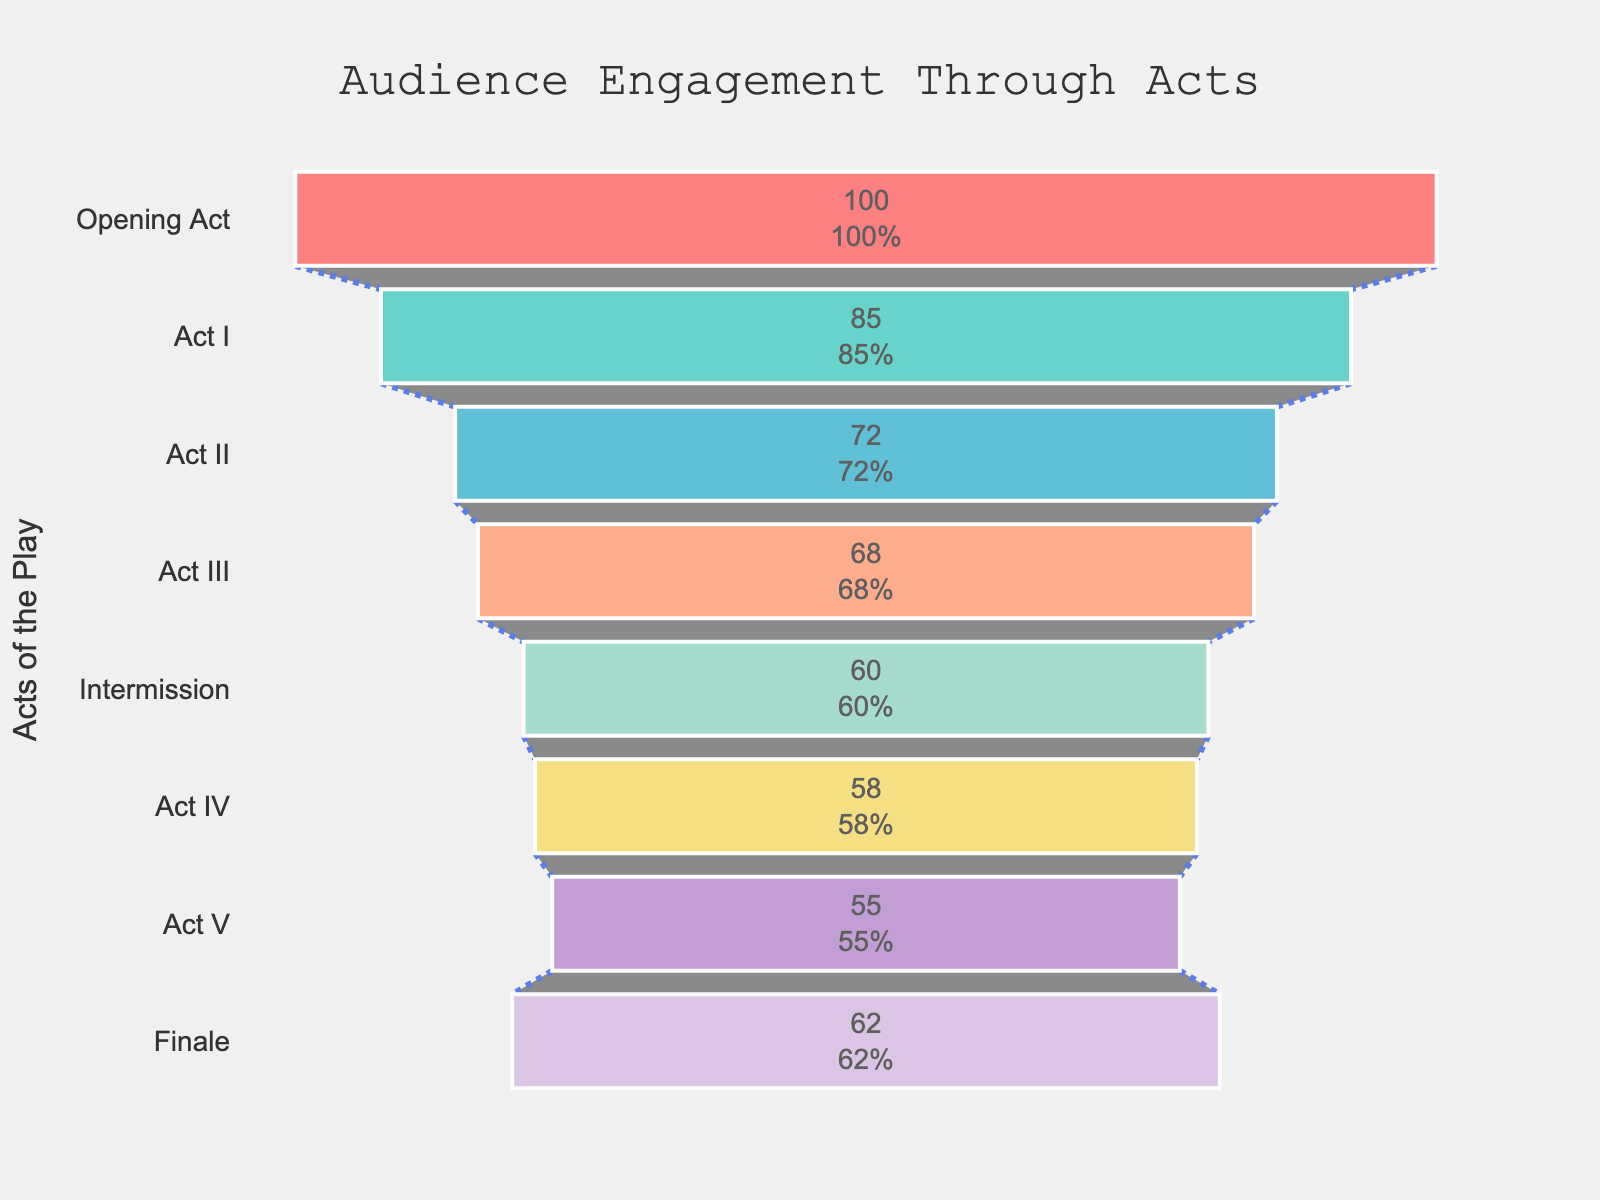What is the title of the funnel chart? The title of the chart is usually displayed prominently at the top of the figure and in this case, it reads "Audience Engagement Through Acts".
Answer: Audience Engagement Through Acts What are the highest and lowest levels of audience engagement? The highest engagement level can be found by looking for the tallest bar, which corresponds to the "Opening Act" with 100. The lowest is represented by the shortest bar, which is "Act V" at 55.
Answer: Highest: 100, Lowest: 55 What's the difference in audience engagement between the Opening Act and the Finale? First, identify the values of engagement for the Opening Act (100) and the Finale (62). Then, subtract the Finale's value from the Opening Act's value (100 - 62).
Answer: 38 Which act had an engagement level of 68? Look for the bar labeled with an engagement level of 68. The corresponding act is "Act III".
Answer: Act III How many acts have an audience engagement level greater than 70? Locate the bars whose values are higher than 70: Opening Act (100), Act I (85), Act II (72). Count these bars.
Answer: 3 By how much did the engagement level drop from Act II to Intermission? Identify the engagement levels of Act II (72) and Intermission (60). Subtract Intermission’s engagement from Act II’s engagement (72 - 60).
Answer: 12 Which act saw the biggest drop in engagement compared to the previous act? Calculate the difference in engagement levels between each pair of consecutive acts and identify the largest drop. The biggest drop is between the Opening Act (100) to Act I (85), which is 15. Similarly review other drops but this one is the greatest.
Answer: Act I What percentage of the initial engagement level did the audience retain by the end of Act V? Note the initial engagement level is 100, and for Act V it is 55. Calculate the percentage as (55/100)*100.
Answer: 55% Is there any part of the play where the engagement level increases from the previous act? Scan through the values to check for any increase. The only increase is from Act V (55) to the Finale (62).
Answer: Yes, between Act V and Finale What is the engagement level during the Intermission? Directly reference the bar labeled "Intermission" for the value, which is 60.
Answer: 60 